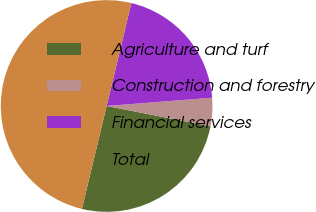Convert chart to OTSL. <chart><loc_0><loc_0><loc_500><loc_500><pie_chart><fcel>Agriculture and turf<fcel>Construction and forestry<fcel>Financial services<fcel>Total<nl><fcel>25.68%<fcel>4.32%<fcel>20.0%<fcel>50.0%<nl></chart> 